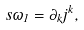Convert formula to latex. <formula><loc_0><loc_0><loc_500><loc_500>s \omega _ { 1 } = \partial _ { k } j ^ { k } ,</formula> 